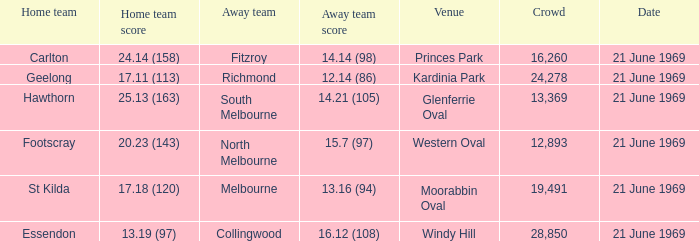When did an away team score 15.7 (97)? 21 June 1969. 